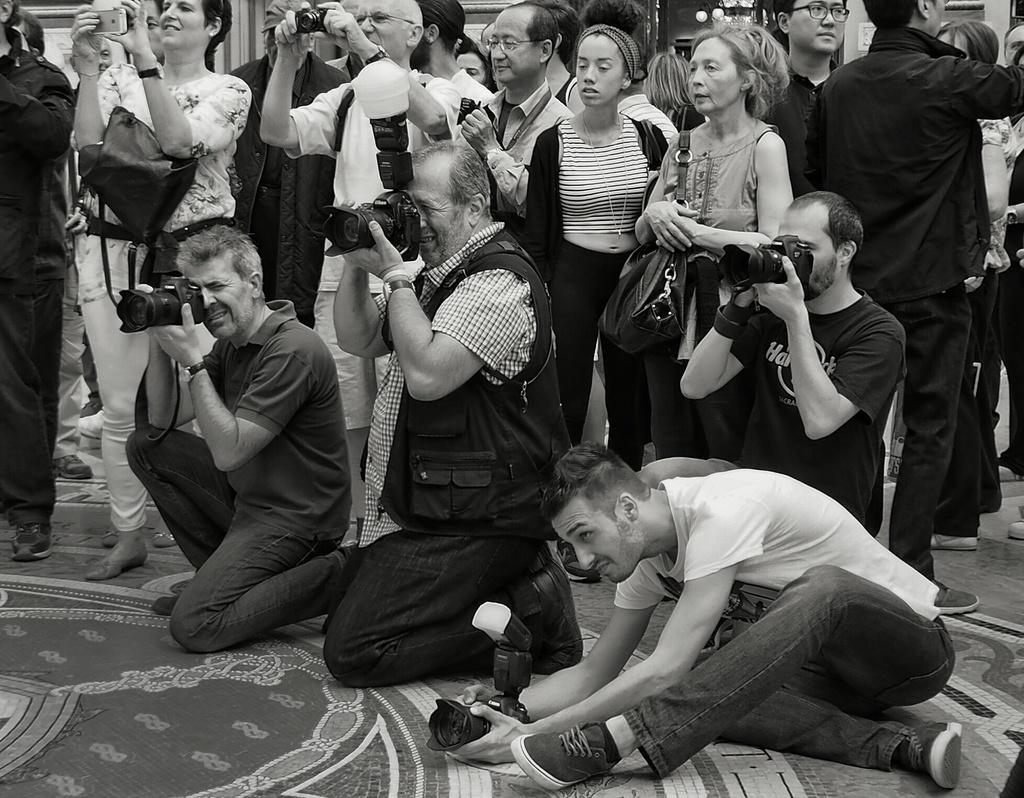What is happening in the image? There are people standing in the image. What are some of the people doing in the image? Four of the people are holding cameras. Can you describe the woman in the image? A woman is carrying a bag. What type of form is the kitten filling out in the image? There is no kitten or form present in the image. How many clouds can be seen in the image? There is no mention of clouds in the image, as it focuses on people standing and holding cameras. 